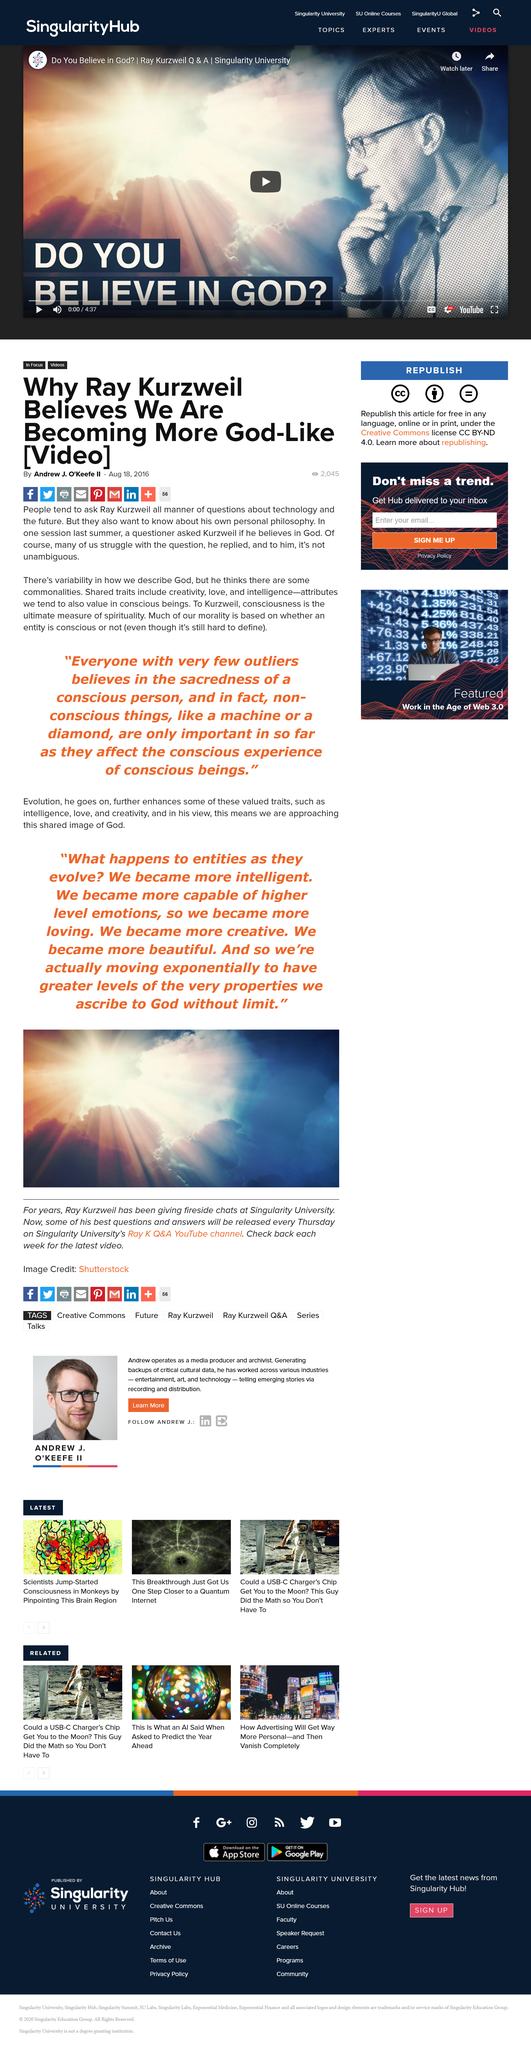Outline some significant characteristics in this image. The author of the article is named Andrew. In the year 2016, the article was written. The article is about a man named Ray. 